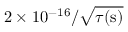<formula> <loc_0><loc_0><loc_500><loc_500>2 \times 1 0 ^ { - 1 6 } / \sqrt { \tau ( s ) }</formula> 